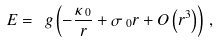<formula> <loc_0><loc_0><loc_500><loc_500>E = \ g \left ( - \frac { \kappa _ { \text { 0} } } { r } + \sigma _ { \text { 0} } r + O \left ( r ^ { 3 } \right ) \right ) \, ,</formula> 